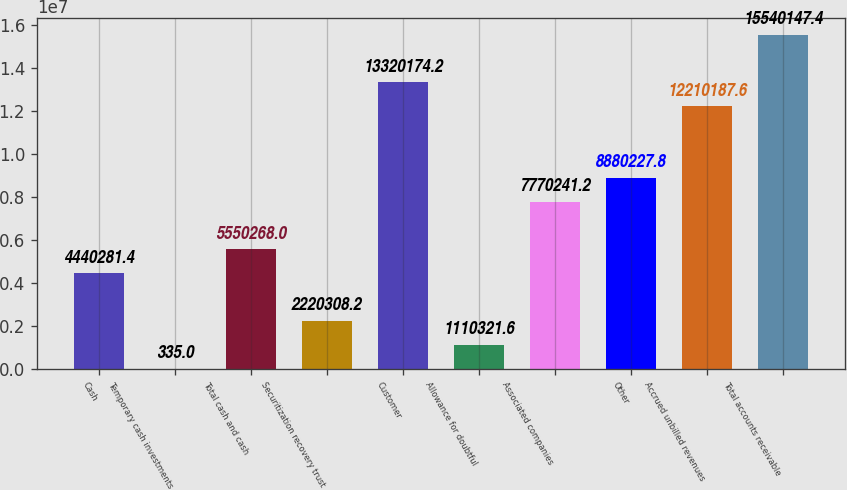Convert chart to OTSL. <chart><loc_0><loc_0><loc_500><loc_500><bar_chart><fcel>Cash<fcel>Temporary cash investments<fcel>Total cash and cash<fcel>Securitization recovery trust<fcel>Customer<fcel>Allowance for doubtful<fcel>Associated companies<fcel>Other<fcel>Accrued unbilled revenues<fcel>Total accounts receivable<nl><fcel>4.44028e+06<fcel>335<fcel>5.55027e+06<fcel>2.22031e+06<fcel>1.33202e+07<fcel>1.11032e+06<fcel>7.77024e+06<fcel>8.88023e+06<fcel>1.22102e+07<fcel>1.55401e+07<nl></chart> 